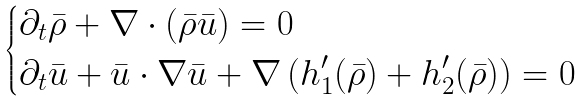Convert formula to latex. <formula><loc_0><loc_0><loc_500><loc_500>\begin{dcases} \partial _ { t } \bar { \rho } + \nabla \cdot ( \bar { \rho } \bar { u } ) = 0 \\ \partial _ { t } \bar { u } + \bar { u } \cdot \nabla \bar { u } + \nabla \left ( h _ { 1 } ^ { \prime } ( \bar { \rho } ) + h _ { 2 } ^ { \prime } ( \bar { \rho } ) \right ) = 0 \end{dcases}</formula> 